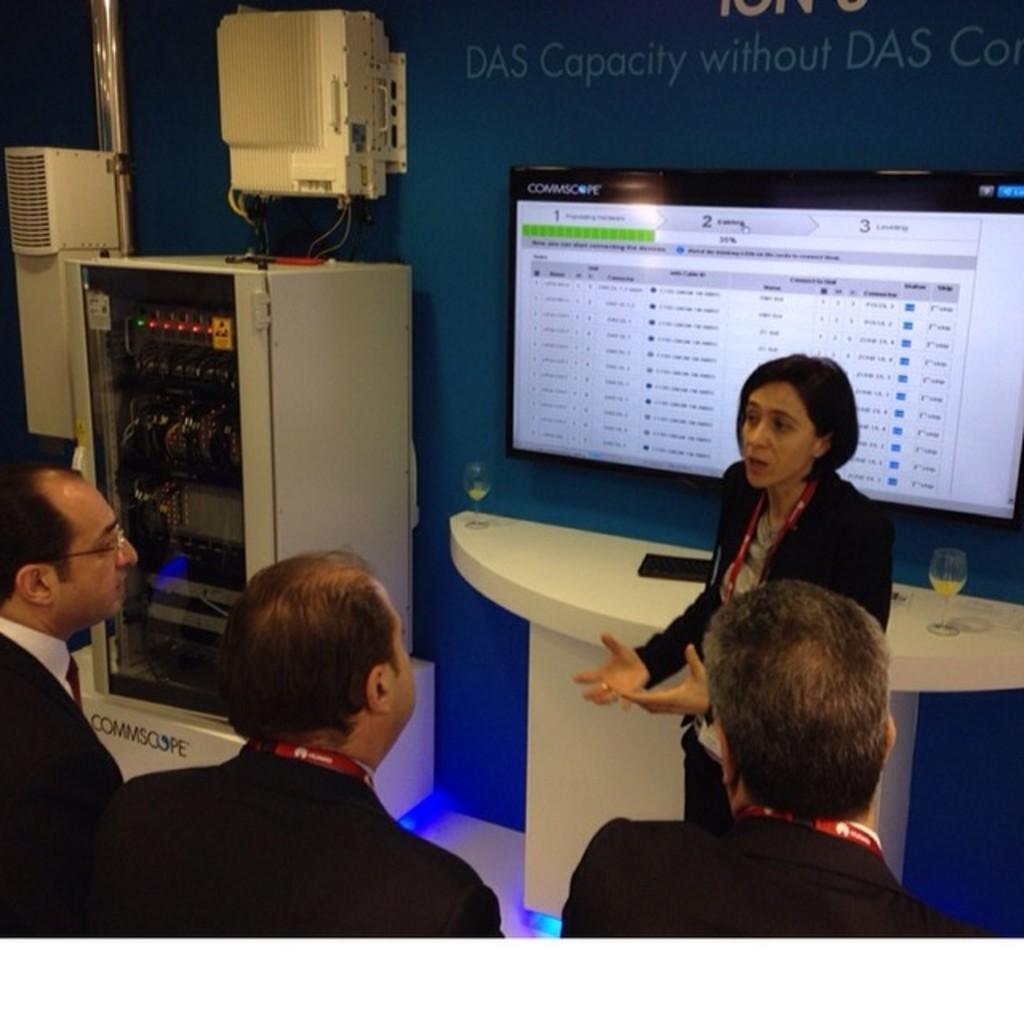How would you summarize this image in a sentence or two? In this picture there is a woman who is wearing blazer, t-shirt and trouser. She is standing near to the table. On the table I can see the juice glasses, mouse and keyboard. At the bottom there are three men who are wearing the same dress. On the right there is a television screen which is placed on the wall. On the left I can see some machine near to the cooler. 